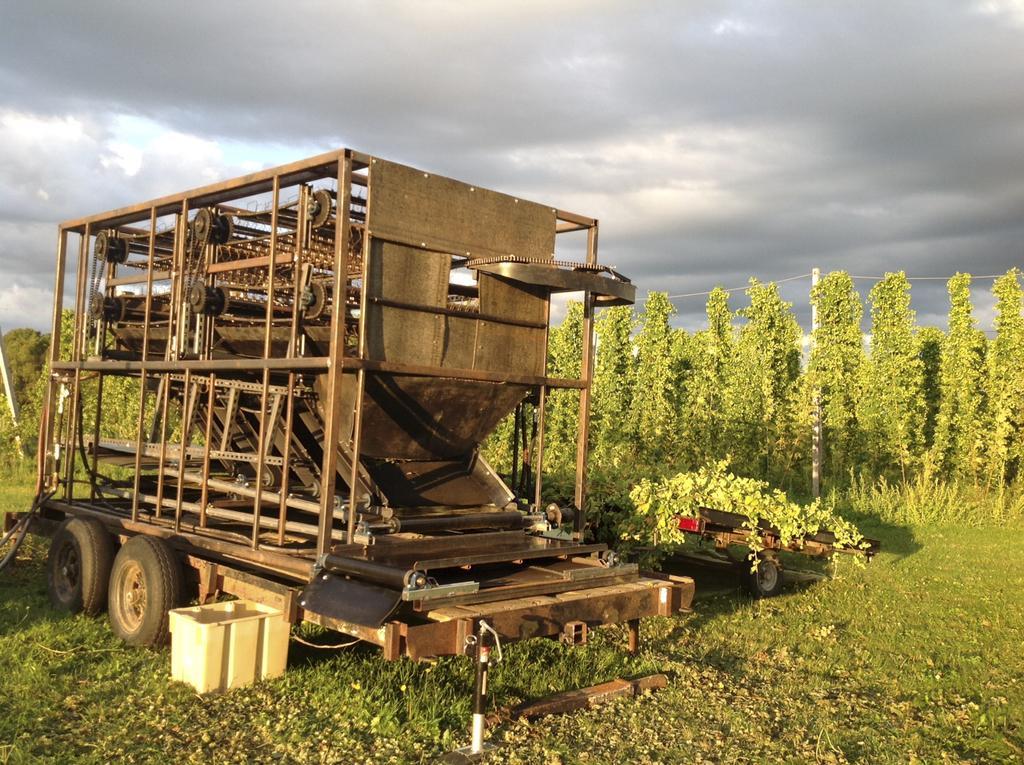Describe this image in one or two sentences. We can see vehicle and cart on the grass. In the background we can see trees,pole with wires and sky. 